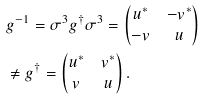<formula> <loc_0><loc_0><loc_500><loc_500>& g ^ { - 1 } = \sigma ^ { 3 } g ^ { \dagger } \sigma ^ { 3 } = \begin{pmatrix} u ^ { * } & - v ^ { * } \\ - v & u \end{pmatrix} \\ & \neq g ^ { \dagger } = \begin{pmatrix} u ^ { * } & v ^ { * } \\ v & u \end{pmatrix} .</formula> 